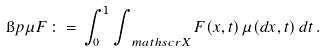Convert formula to latex. <formula><loc_0><loc_0><loc_500><loc_500>\i p { \mu } { F } \, \colon = \, \int _ { 0 } ^ { 1 } \int _ { \ m a t h s c r { X } } F ( x , t ) \, \mu ( d x , t ) \, d t \, .</formula> 